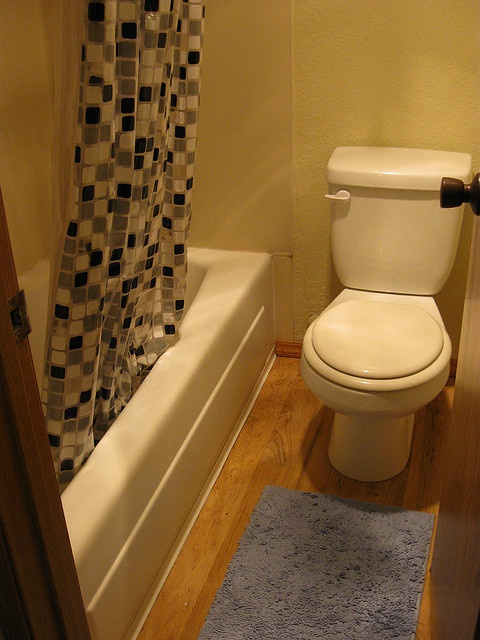Describe the objects in this image and their specific colors. I can see a toilet in brown, tan, and maroon tones in this image. 